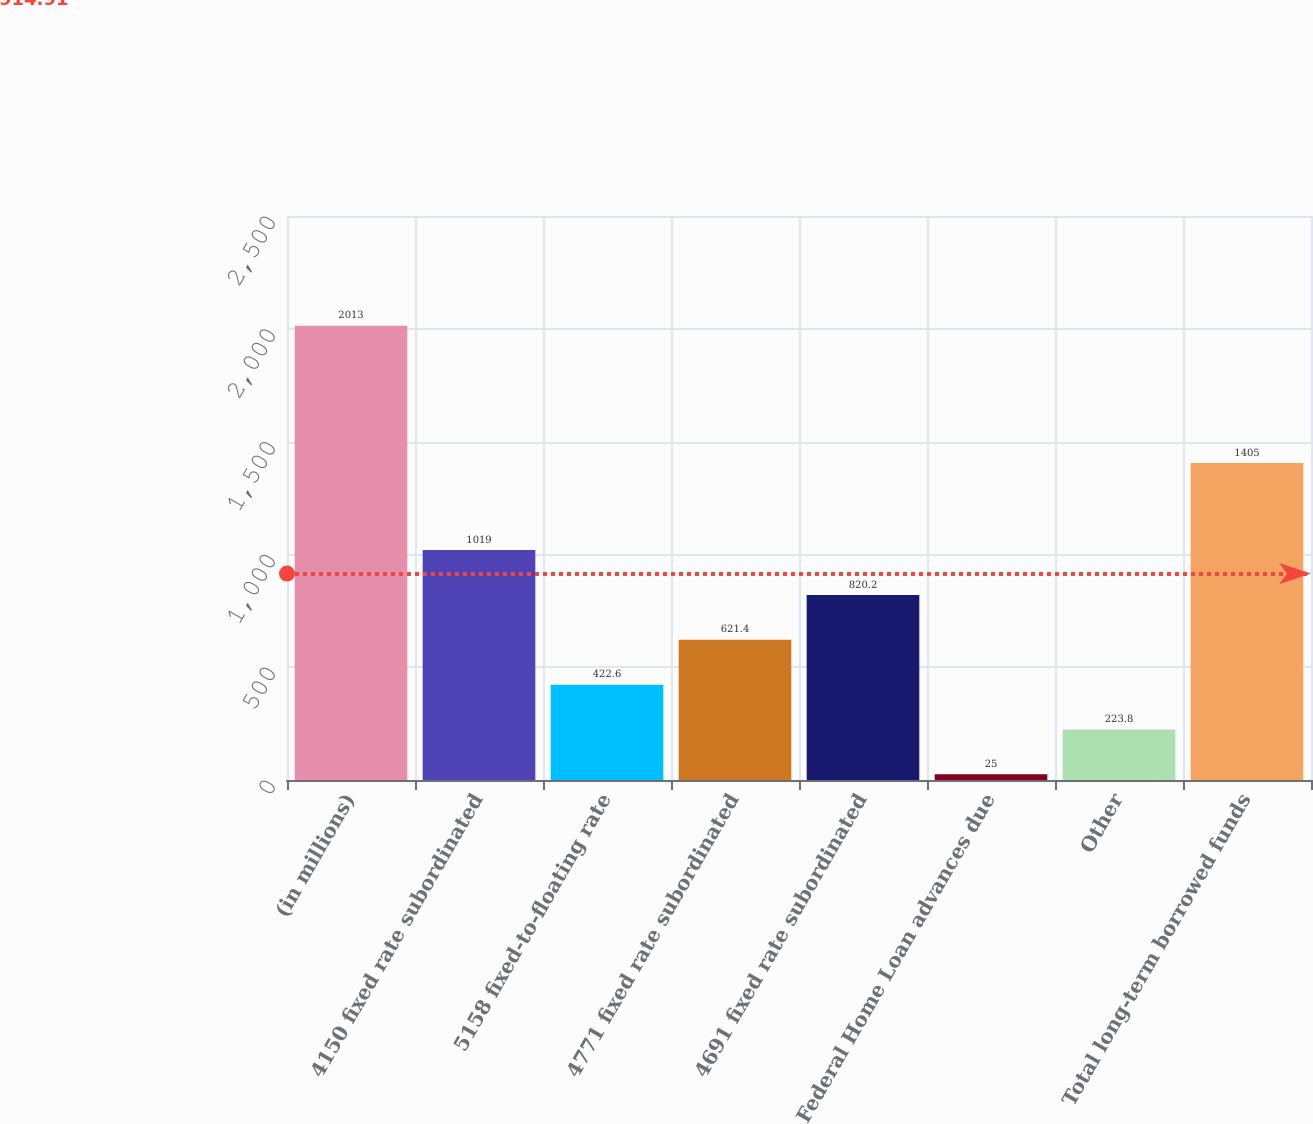Convert chart to OTSL. <chart><loc_0><loc_0><loc_500><loc_500><bar_chart><fcel>(in millions)<fcel>4150 fixed rate subordinated<fcel>5158 fixed-to-floating rate<fcel>4771 fixed rate subordinated<fcel>4691 fixed rate subordinated<fcel>Federal Home Loan advances due<fcel>Other<fcel>Total long-term borrowed funds<nl><fcel>2013<fcel>1019<fcel>422.6<fcel>621.4<fcel>820.2<fcel>25<fcel>223.8<fcel>1405<nl></chart> 